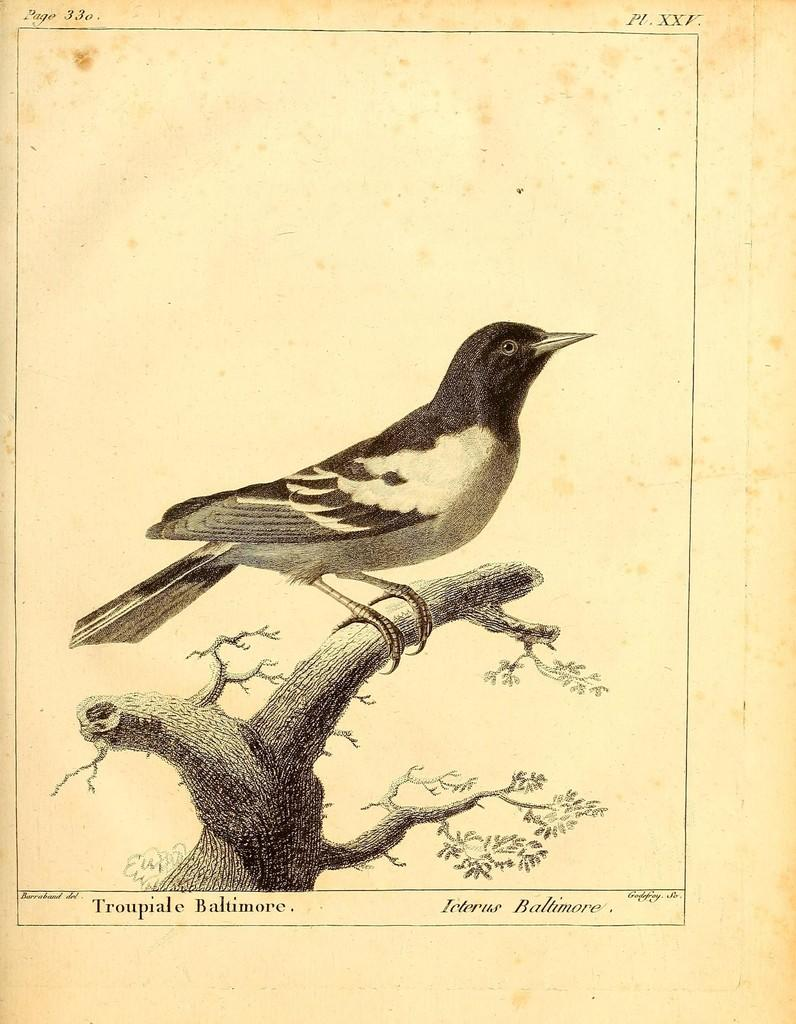What type of visual is depicted in the image? The image is a poster. What is the main subject of the poster? The poster features a bird. Where is the bird located in the image? The bird is standing on a branch. Are there any additional design elements on the poster? Yes, there are watermarks at the top and bottom of the image. What type of flesh can be seen on the bird in the image? There is no flesh visible on the bird in the image, as it is a drawing or illustration of a bird. Can you hear any thunder in the image? There is no sound in the image, so it is not possible to hear thunder or any other sounds. 